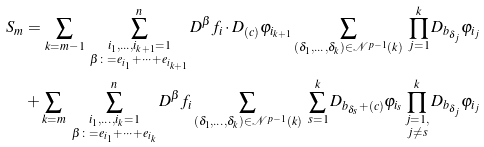Convert formula to latex. <formula><loc_0><loc_0><loc_500><loc_500>S _ { m } & = \sum _ { k = m - 1 } \ \sum _ { \substack { i _ { 1 } , \dots , i _ { k + 1 } = 1 \\ \beta \colon = e _ { i _ { 1 } } + \cdots + e _ { i _ { k + 1 } } } } ^ { n } D ^ { \beta } f _ { i } \cdot D _ { ( c ) } \varphi _ { i _ { k + 1 } } \sum _ { ( \delta _ { 1 } , \dots , \delta _ { k } ) \in \mathcal { N } ^ { p - 1 } ( k ) } \ \prod _ { j = 1 } ^ { k } D _ { b _ { \delta _ { j } } } \varphi _ { i _ { j } } \\ & + \sum _ { k = m } \ \sum _ { \substack { i _ { 1 } , \dots , i _ { k } = 1 \\ \beta \colon = e _ { i _ { 1 } } + \cdots + e _ { i _ { k } } } } ^ { n } D ^ { \beta } f _ { i } \sum _ { ( \delta _ { 1 } , \dots , \delta _ { k } ) \in \mathcal { N } ^ { p - 1 } ( k ) } \ \sum _ { s = 1 } ^ { k } D _ { b _ { \delta _ { s } } + ( c ) } \varphi _ { i _ { s } } \prod _ { \substack { j = 1 , \\ j \neq s } } ^ { k } D _ { b _ { \delta _ { j } } } \varphi _ { i _ { j } }</formula> 